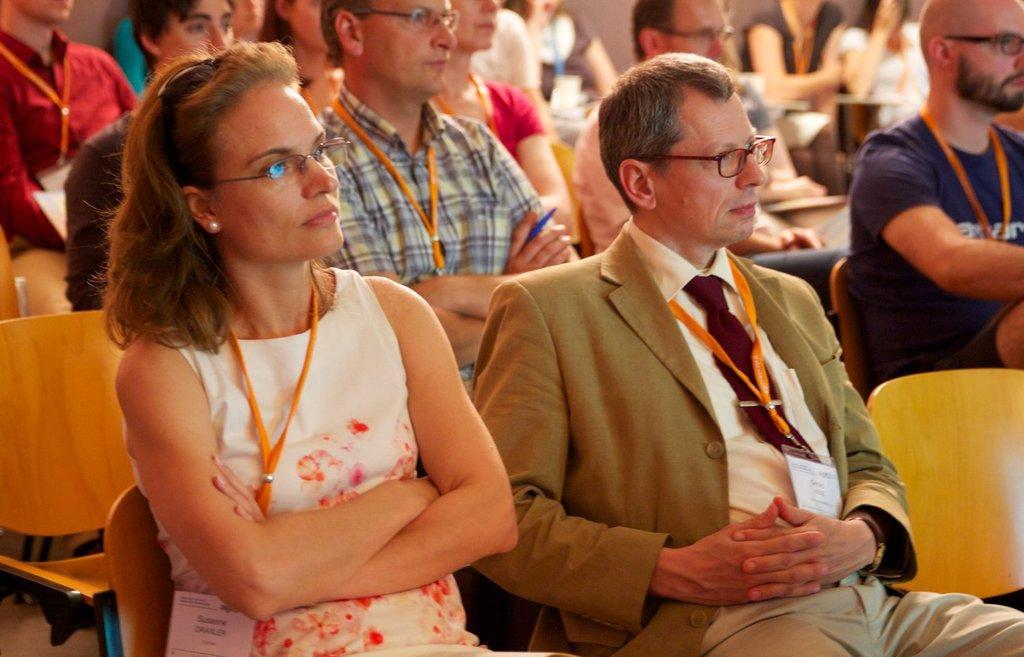How would you summarize this image in a sentence or two? In this picture I can see here are a few people sitting on the chairs and they have ID cards, spectacles and they are looking at the right side. 